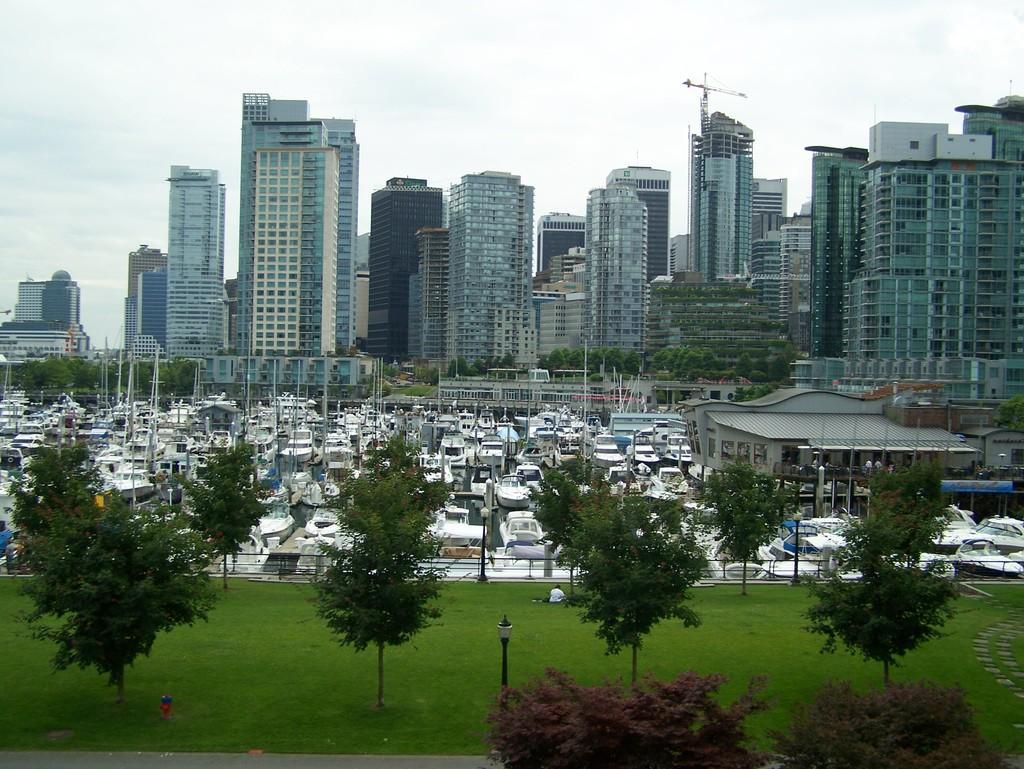In one or two sentences, can you explain what this image depicts? This image is taken outdoors. At the bottom of the image there is a ground with grass on it and there are a few trees. In the middle of the image there are many boats and ships. In the background there are many buildings and houses with walls, windows, doors, roofs, railings and balconies. At the top of the image there is a sky with clouds. 